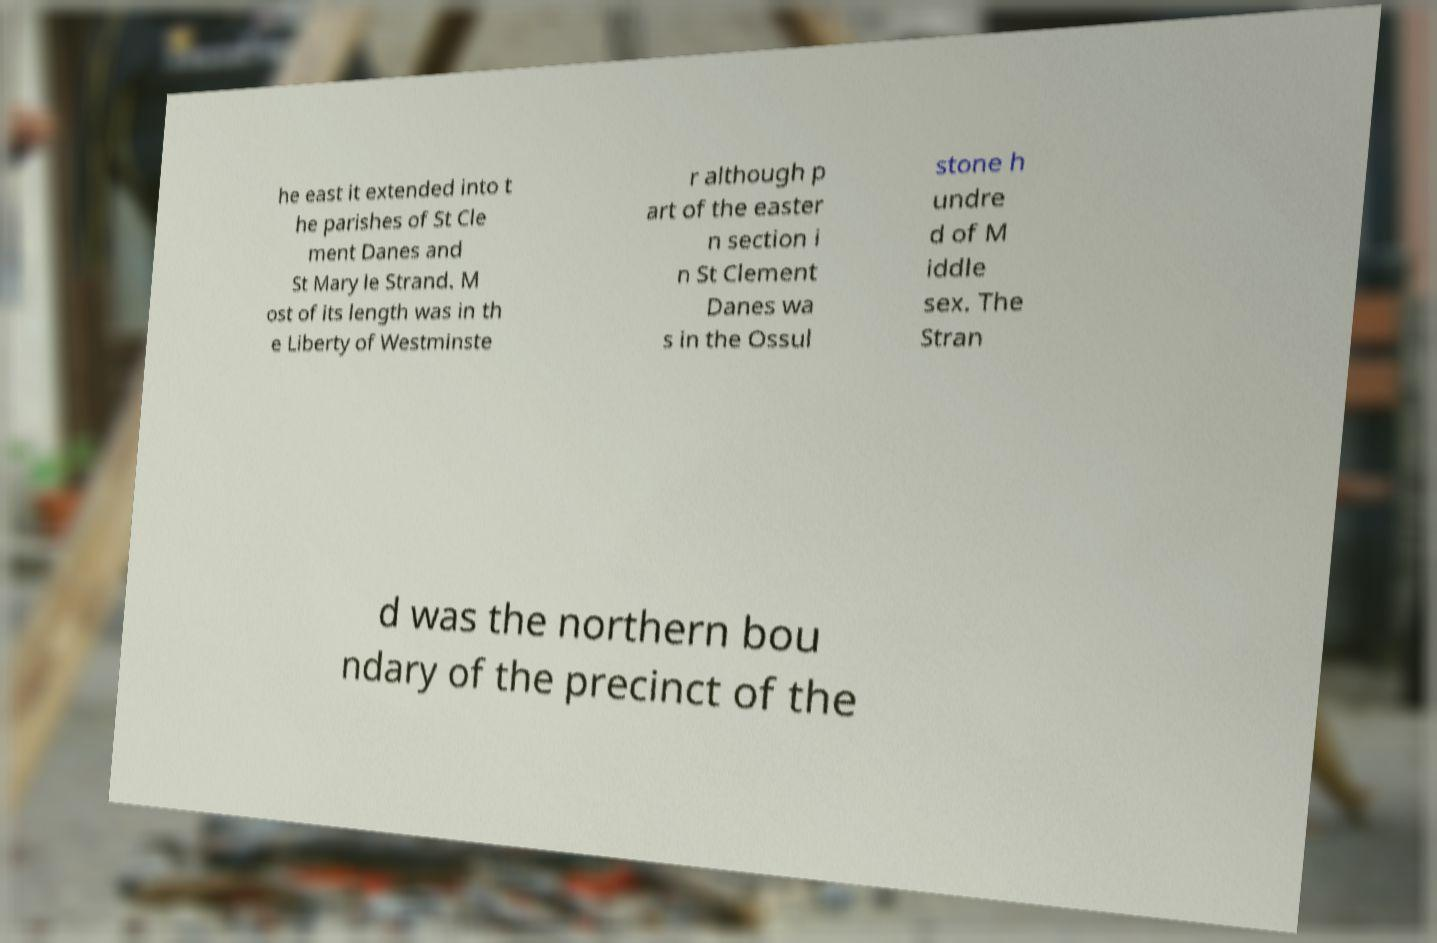For documentation purposes, I need the text within this image transcribed. Could you provide that? he east it extended into t he parishes of St Cle ment Danes and St Mary le Strand. M ost of its length was in th e Liberty of Westminste r although p art of the easter n section i n St Clement Danes wa s in the Ossul stone h undre d of M iddle sex. The Stran d was the northern bou ndary of the precinct of the 